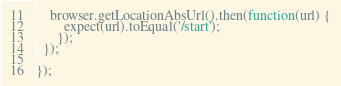Convert code to text. <code><loc_0><loc_0><loc_500><loc_500><_JavaScript_>    browser.getLocationAbsUrl().then(function(url) {
        expect(url).toEqual('/start');
      });
  });

});
</code> 